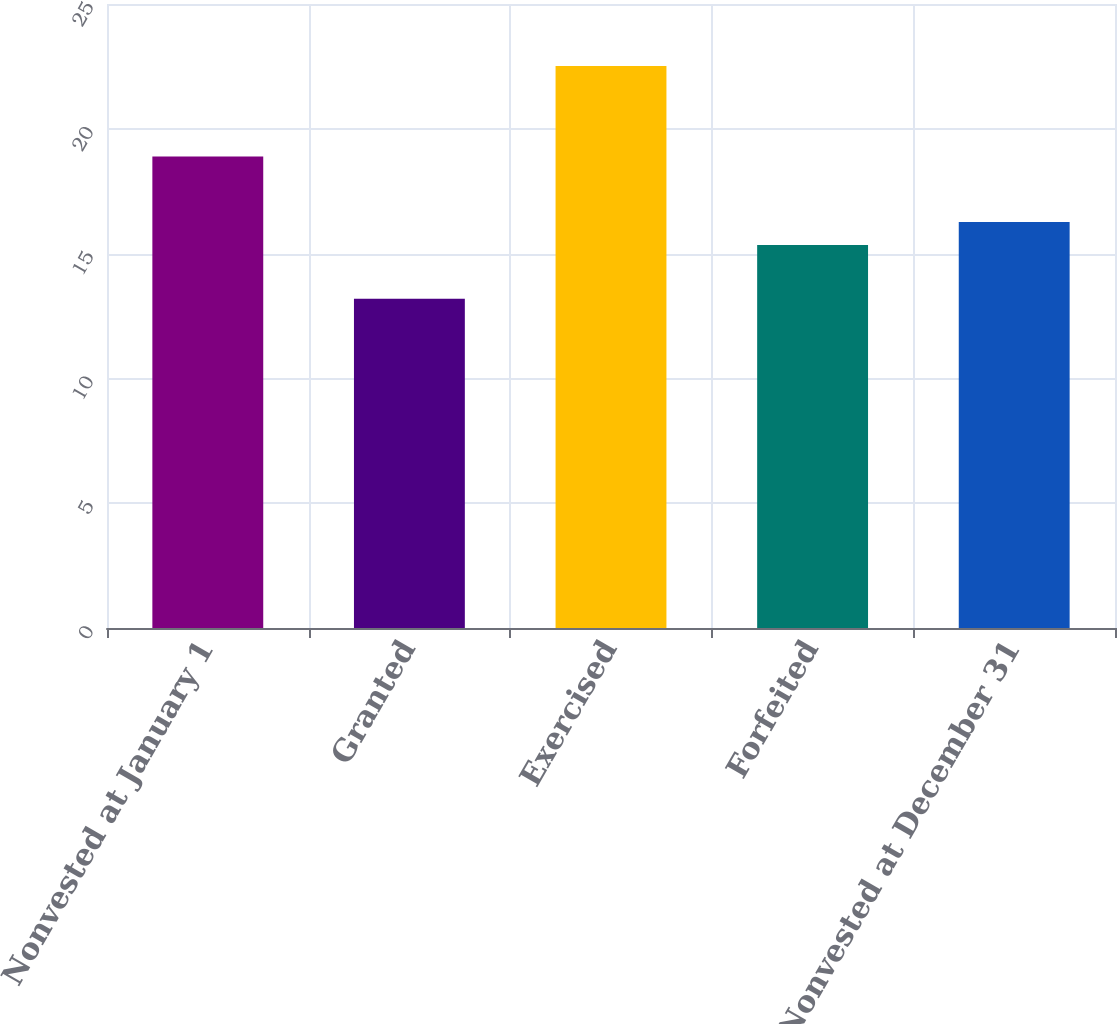Convert chart to OTSL. <chart><loc_0><loc_0><loc_500><loc_500><bar_chart><fcel>Nonvested at January 1<fcel>Granted<fcel>Exercised<fcel>Forfeited<fcel>Nonvested at December 31<nl><fcel>18.89<fcel>13.19<fcel>22.52<fcel>15.34<fcel>16.27<nl></chart> 